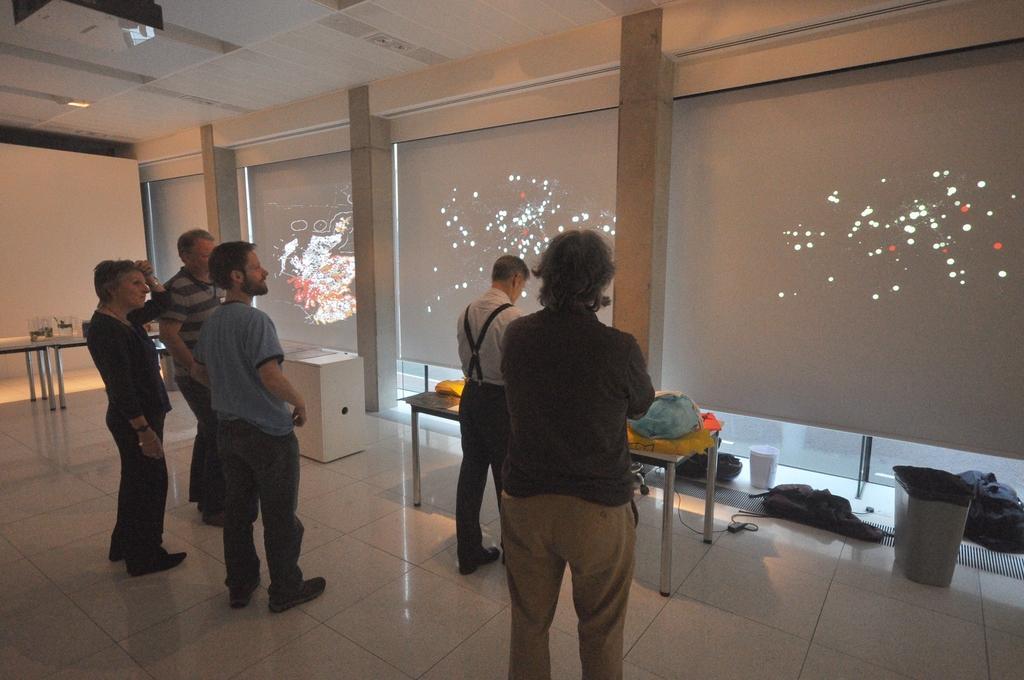How would you summarize this image in a sentence or two? This persons are standing. This posters are colorful. On this table there is a jar. On this table there are things. This is bin on floor. 